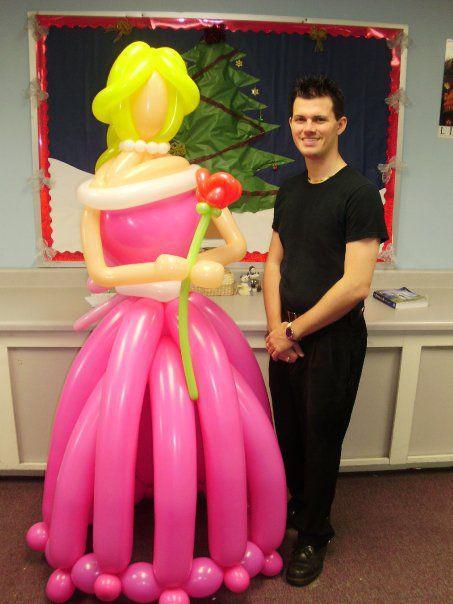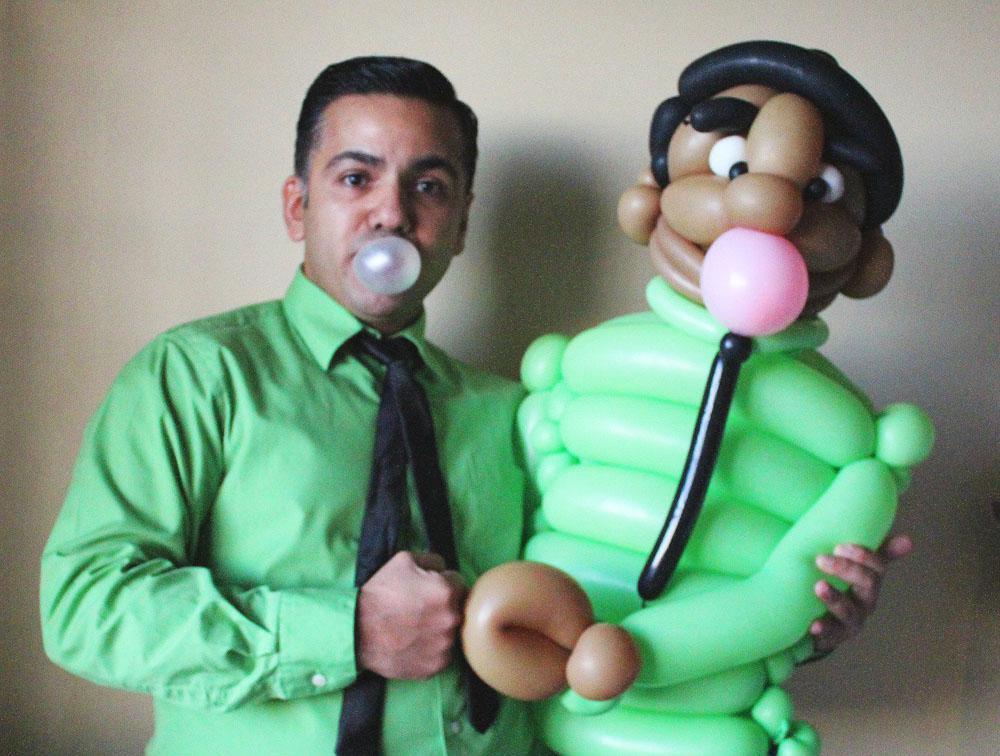The first image is the image on the left, the second image is the image on the right. For the images displayed, is the sentence "In at least one image there are at least six pink ballons making a skirt." factually correct? Answer yes or no. Yes. The first image is the image on the left, the second image is the image on the right. Given the left and right images, does the statement "The right and left images contain human figures made out of balloons, and one image includes a blond balloon woman wearing a pink skirt." hold true? Answer yes or no. Yes. 